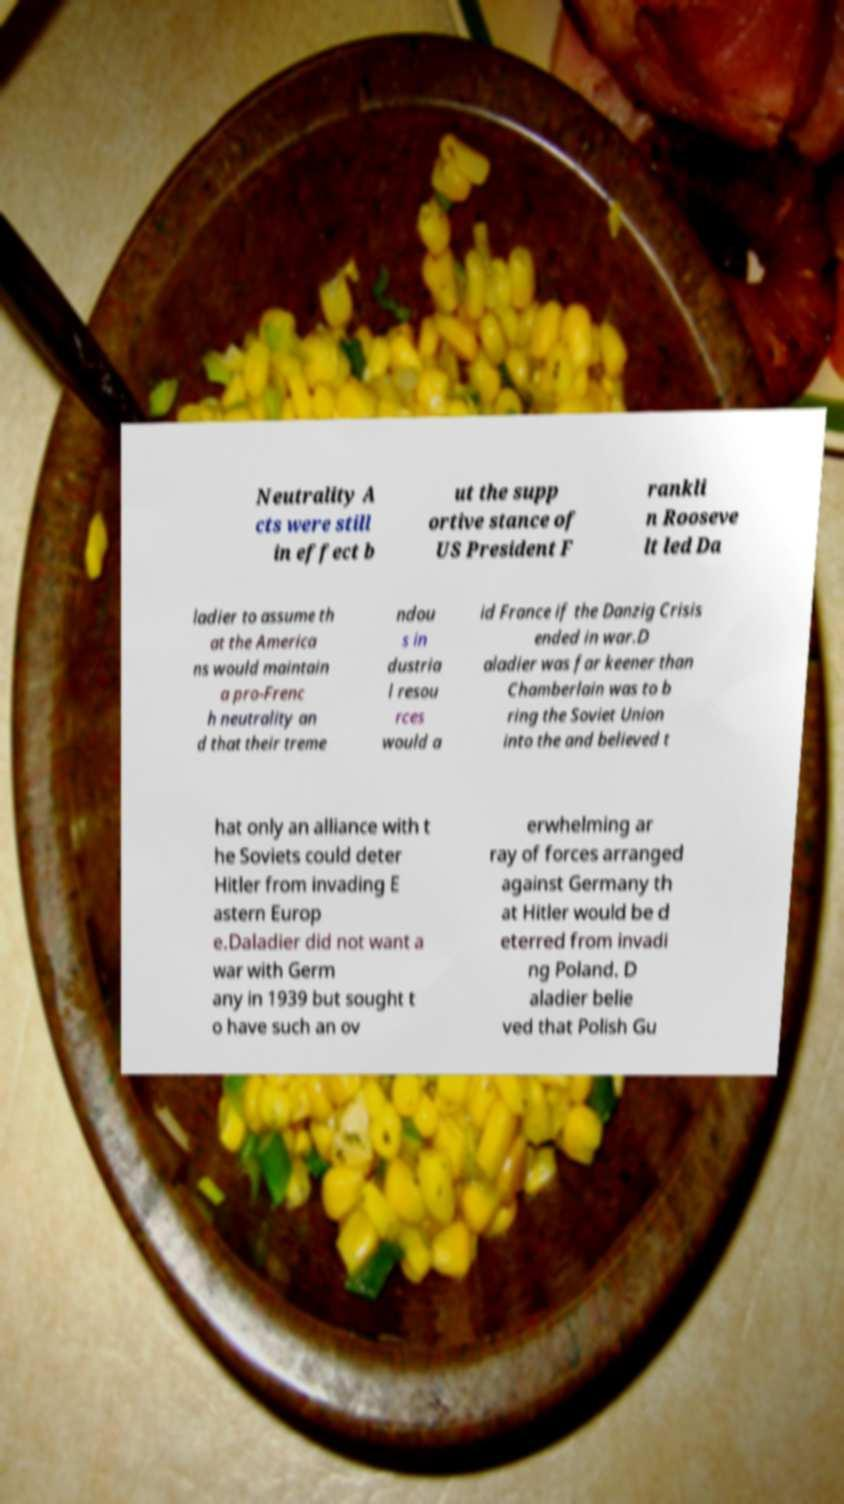There's text embedded in this image that I need extracted. Can you transcribe it verbatim? Neutrality A cts were still in effect b ut the supp ortive stance of US President F rankli n Rooseve lt led Da ladier to assume th at the America ns would maintain a pro-Frenc h neutrality an d that their treme ndou s in dustria l resou rces would a id France if the Danzig Crisis ended in war.D aladier was far keener than Chamberlain was to b ring the Soviet Union into the and believed t hat only an alliance with t he Soviets could deter Hitler from invading E astern Europ e.Daladier did not want a war with Germ any in 1939 but sought t o have such an ov erwhelming ar ray of forces arranged against Germany th at Hitler would be d eterred from invadi ng Poland. D aladier belie ved that Polish Gu 